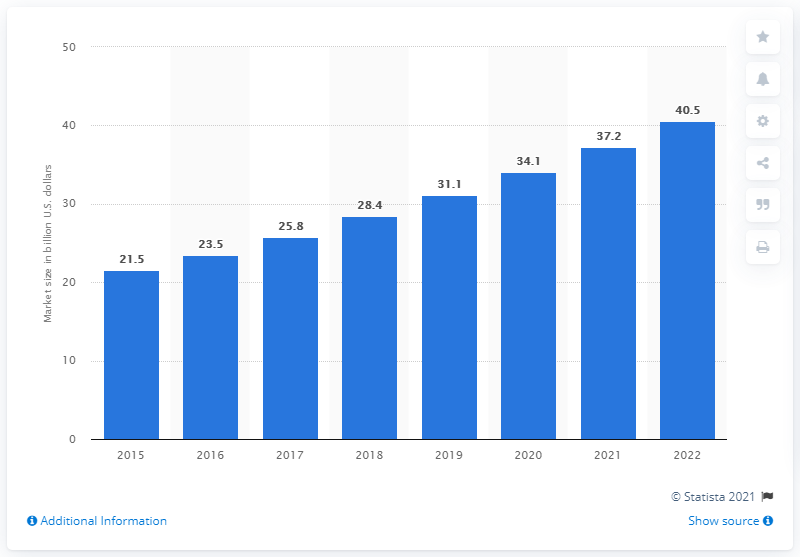List a handful of essential elements in this visual. In 2015, the global market for point of care diagnostics was estimated to be 21.5 billion dollars. 